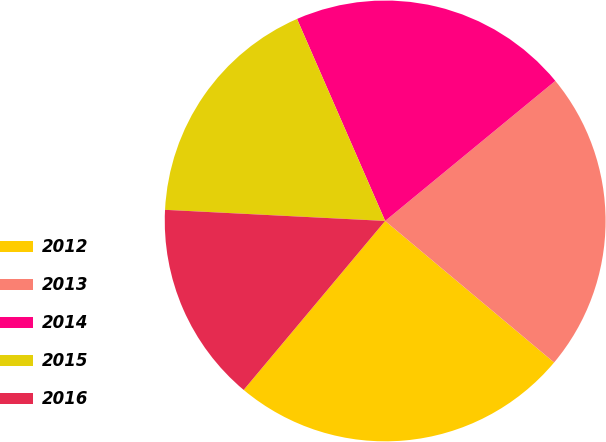<chart> <loc_0><loc_0><loc_500><loc_500><pie_chart><fcel>2012<fcel>2013<fcel>2014<fcel>2015<fcel>2016<nl><fcel>25.0%<fcel>22.06%<fcel>20.59%<fcel>17.65%<fcel>14.71%<nl></chart> 